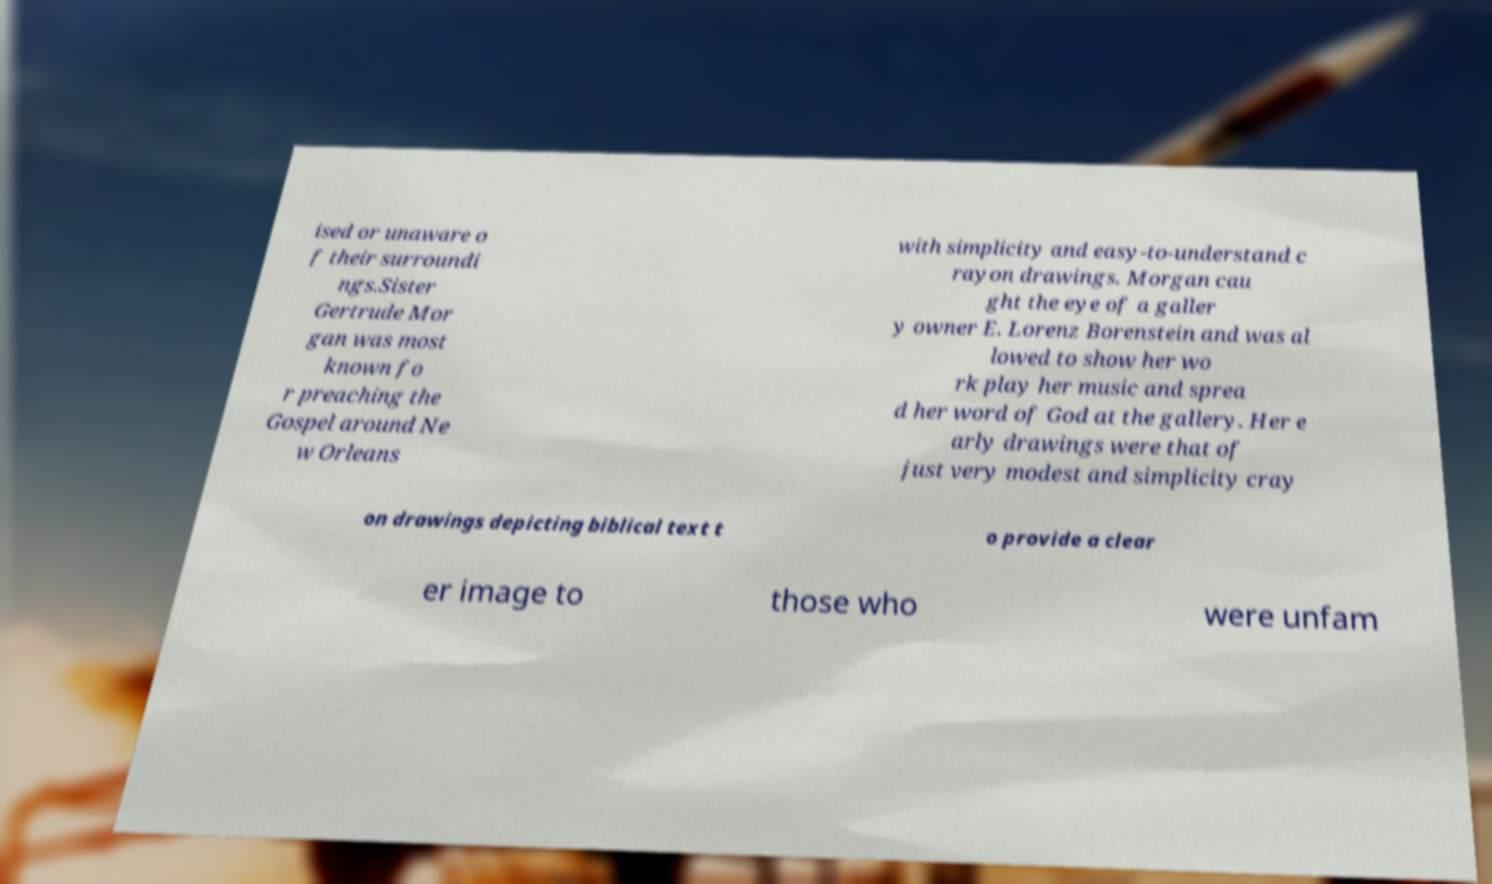What messages or text are displayed in this image? I need them in a readable, typed format. ised or unaware o f their surroundi ngs.Sister Gertrude Mor gan was most known fo r preaching the Gospel around Ne w Orleans with simplicity and easy-to-understand c rayon drawings. Morgan cau ght the eye of a galler y owner E. Lorenz Borenstein and was al lowed to show her wo rk play her music and sprea d her word of God at the gallery. Her e arly drawings were that of just very modest and simplicity cray on drawings depicting biblical text t o provide a clear er image to those who were unfam 